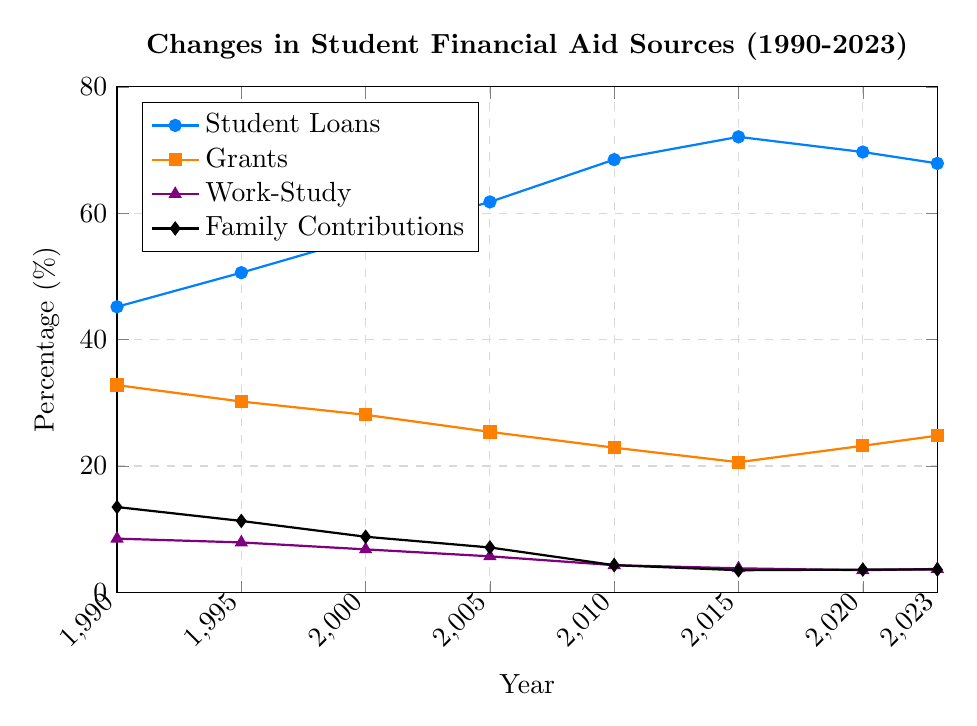What's the overall trend in the percentage of students taking student loans from 1990 to 2023? The percentage of students taking student loans has generally increased from 1990 to 2015, reaching a peak in 2015. After 2015, there is a slight decline in the percentage.
Answer: General increase till 2015, then a slight decline By how much has the percentage of grants decreased from 1990 to 2023? In 1990, the percentage for grants was 32.8%, and by 2023 it decreased to 24.8%. The decrease is calculated as 32.8 - 24.8.
Answer: 8% What is the difference between the highest and lowest percentages of family contributions? The highest percentage for family contributions is 13.5% in 1990, and the lowest is 3.5% in 2015. The difference is calculated as 13.5 - 3.5.
Answer: 10% In which year did work-study see the steepest decline and what was the difference in the percentage from the previous observation? The steepest decline for work-study is between 2005 and 2010, where the percentage dropped from 5.7% to 4.3%. The difference is calculated as 5.7 - 4.3.
Answer: 2005 to 2010, 1.4% Which financial aid source had the smallest percentage change from 1990 to 2023? To find the smallest percentage change, compare the differences from 1990 to 2023 for all sources. Work-study changed from 8.5% to 3.7%, a difference of 4.8%. Student loans increased from 45.2% to 67.9%, a difference of 22.7%. Grants decreased from 32.8% to 24.8%, a difference of 8%. Family contributions decreased from 13.5% to 3.6%, a difference of 9.9%.
Answer: Work-study What is the average percentage of student loans over the given years? Add the percentages of student loans for each year and divide by the number of years: (45.2 + 50.6 + 56.3 + 61.8 + 68.5 + 72.1 + 69.7 + 67.9) / 8.
Answer: 61.5% Which financial aid source showed an increase in its percentage from 2010 to 2023 and by how much? Compare the percentages from 2010 to 2023 for each source. Student loans decreased from 68.5% to 67.9% (decrease of 0.6%), grants increased from 22.9% to 24.8% (increase of 1.9%), work-study increased slightly from 3.5% to 3.7% (0.2%), and family contributions increased from 3.5% to 3.6% (0.1%).
Answer: Grants, 1.9% What is the overall trend of family contributions from 1990 to 2023? The percentage of family contributions has generally decreased from 1990 to 2015 and then remained relatively stable from 2015 to 2023.
Answer: Decrease, then stable Between what years did student loans see the greatest increase in percentage points? The greatest increase in student loans occurs between 2005 and 2010 where the percentage increased from 61.8% to 68.5%. The increase is calculated as 68.5 - 61.8.
Answer: 2005 to 2010 How does the percentage of family contributions in 2023 compare to that of work-study in the same year? The percentage of family contributions in 2023 is 3.6% and the percentage of work-study in the same year is 3.7%. Family contributions are slightly lower than work-study by 0.1%.
Answer: 0.1% lower 